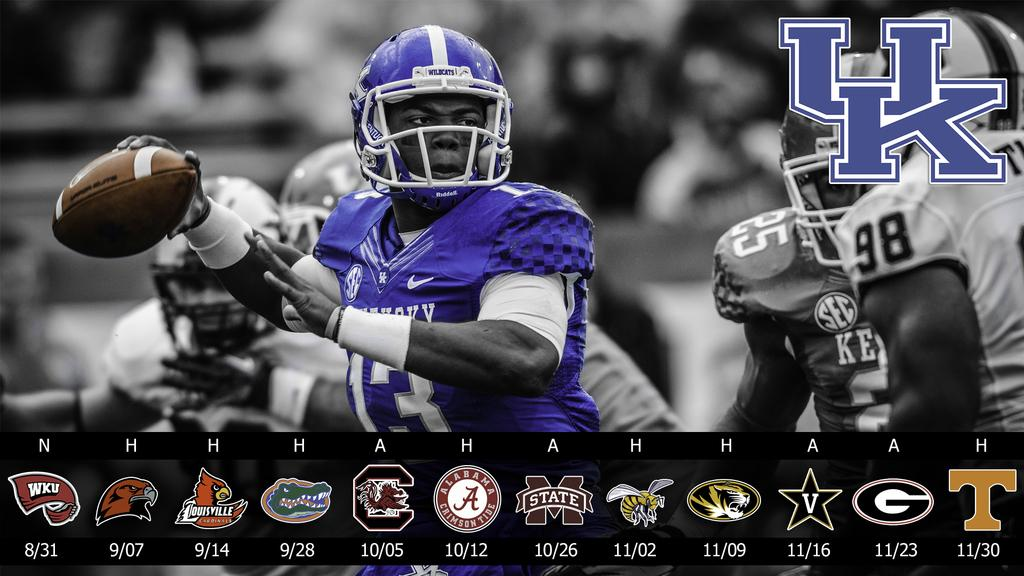How many people are visible in the image? There are a few people in the image. Can you describe the background of the image? The background is blurred. What can be seen on the left side of the image? There is a watermark on the left side of the image. What is located at the bottom of the image? There is a scoreboard with some images at the bottom of the image. What type of offer is being made by the people in the image? There is no indication of an offer being made in the image; it only shows a few people, a blurred background, a watermark, and a scoreboard with images. 